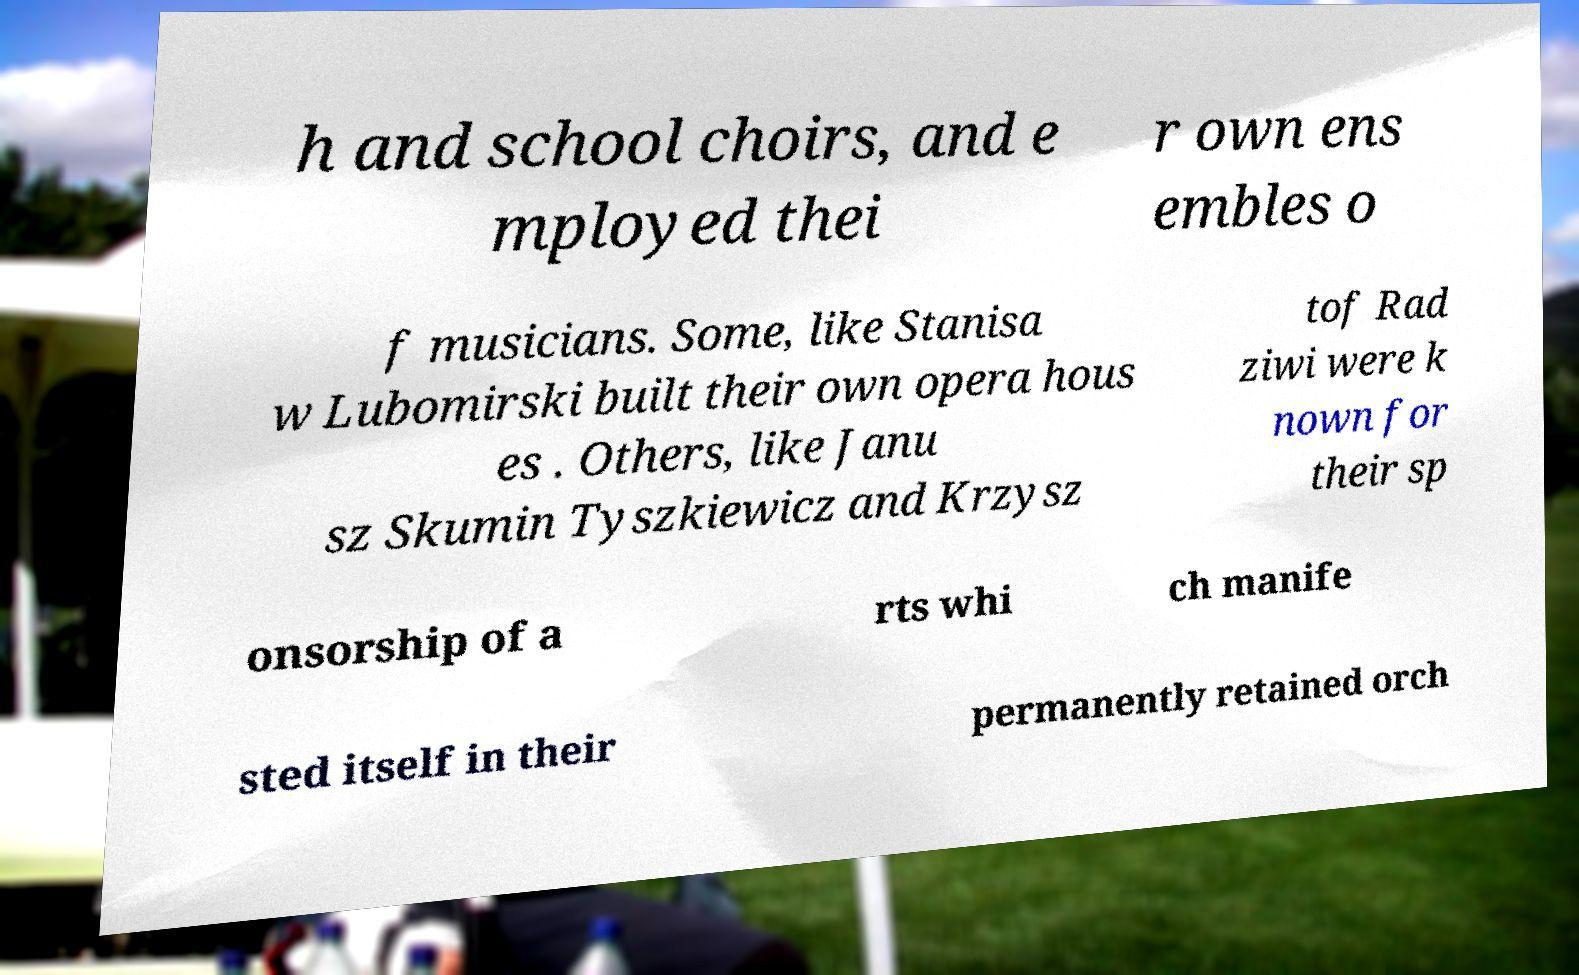Please read and relay the text visible in this image. What does it say? h and school choirs, and e mployed thei r own ens embles o f musicians. Some, like Stanisa w Lubomirski built their own opera hous es . Others, like Janu sz Skumin Tyszkiewicz and Krzysz tof Rad ziwi were k nown for their sp onsorship of a rts whi ch manife sted itself in their permanently retained orch 